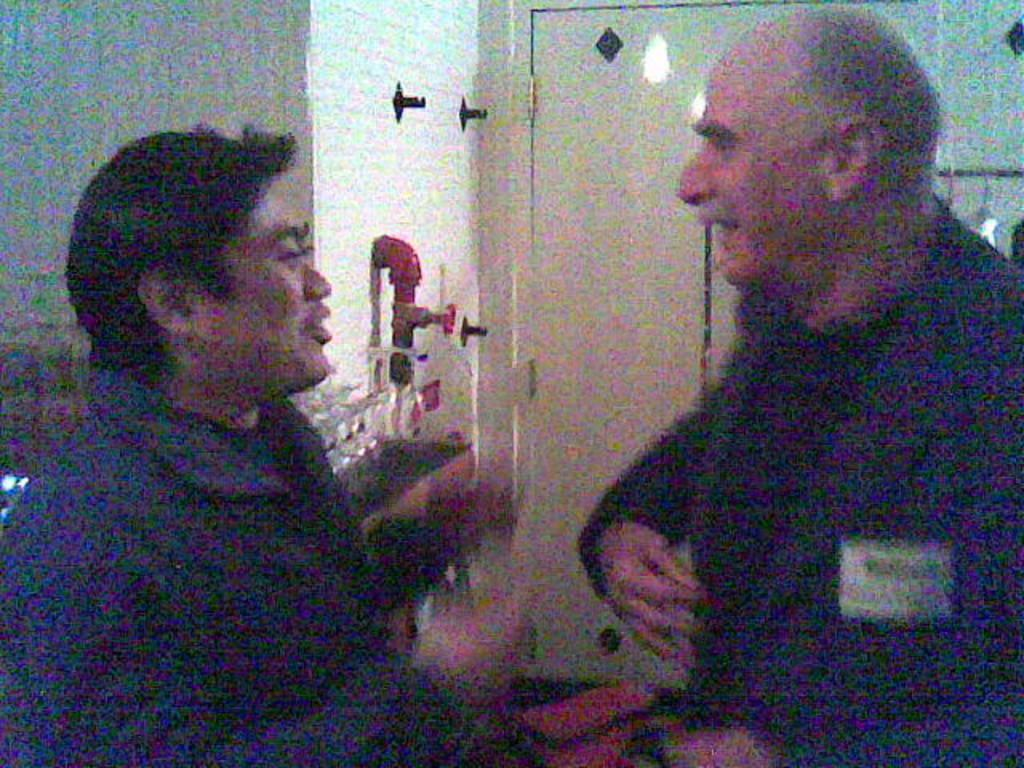How many people are present in the image? There are two persons in the image. What are the two persons doing? The two persons are talking. Can you describe any architectural features in the image? Yes, there is a door in the middle of the image. What type of farm animals can be seen in the image? There are no farm animals present in the image. What type of utensil is being used by the persons in the image? There is no utensil visible in the image. What type of boats can be seen in the image? There is no harbor or boats present in the image. 